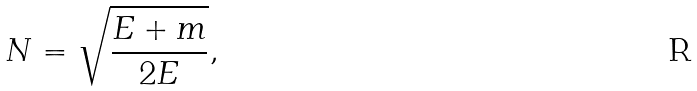<formula> <loc_0><loc_0><loc_500><loc_500>N = \sqrt { \frac { E + m } { 2 E } } ,</formula> 